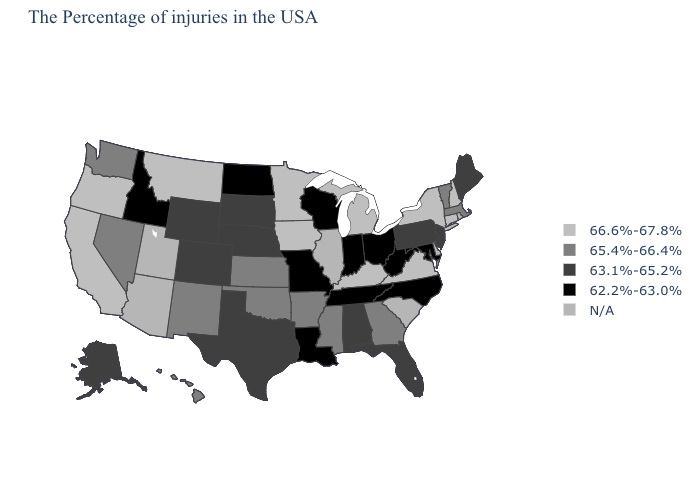What is the value of Georgia?
Short answer required. 65.4%-66.4%. How many symbols are there in the legend?
Short answer required. 5. What is the highest value in the USA?
Give a very brief answer. 66.6%-67.8%. Name the states that have a value in the range 66.6%-67.8%?
Concise answer only. New Hampshire, Connecticut, New York, Virginia, Michigan, Kentucky, Minnesota, Iowa, Montana, California, Oregon. Is the legend a continuous bar?
Answer briefly. No. What is the value of Colorado?
Short answer required. 63.1%-65.2%. What is the highest value in states that border Illinois?
Write a very short answer. 66.6%-67.8%. What is the value of Georgia?
Write a very short answer. 65.4%-66.4%. What is the highest value in states that border Michigan?
Keep it brief. 62.2%-63.0%. Which states hav the highest value in the West?
Concise answer only. Montana, California, Oregon. Which states have the lowest value in the USA?
Answer briefly. Maryland, North Carolina, West Virginia, Ohio, Indiana, Tennessee, Wisconsin, Louisiana, Missouri, North Dakota, Idaho. Is the legend a continuous bar?
Be succinct. No. What is the value of South Dakota?
Short answer required. 63.1%-65.2%. Does the map have missing data?
Quick response, please. Yes. How many symbols are there in the legend?
Give a very brief answer. 5. 